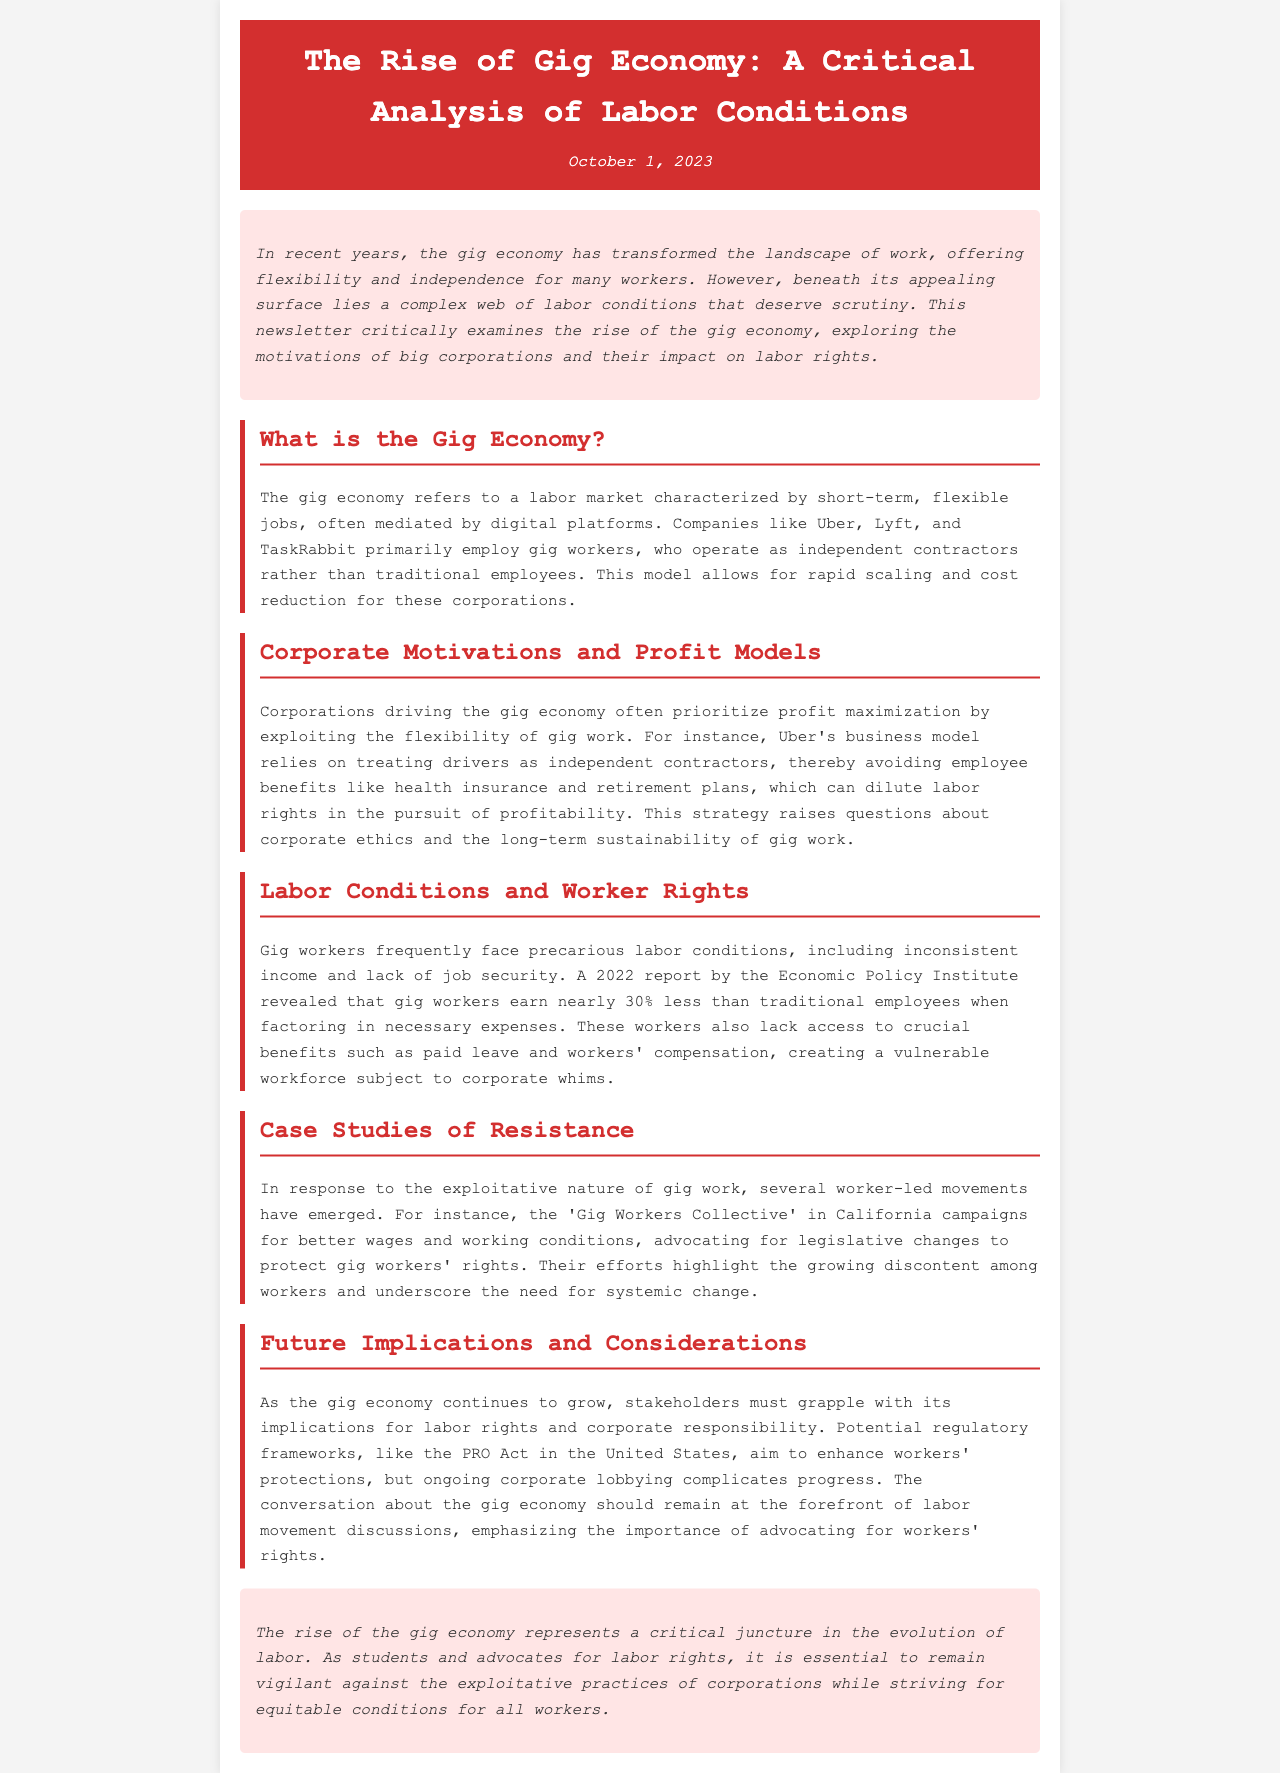What is the date of the newsletter? The date mentioned in the newsletter is October 1, 2023.
Answer: October 1, 2023 Who are some companies mentioned in the gig economy section? The newsletter lists Uber, Lyft, and TaskRabbit as examples of companies in the gig economy.
Answer: Uber, Lyft, TaskRabbit What percentage less do gig workers earn compared to traditional employees? According to the 2022 report, gig workers earn nearly 30% less than traditional employees.
Answer: 30% What is the name of the campaign mentioned for gig workers' rights? The organization campaigning for better wages and working conditions for gig workers is called the 'Gig Workers Collective.'
Answer: Gig Workers Collective What is one potential regulatory framework mentioned that aims to enhance workers’ protections? The newsletter refers to the PRO Act as a regulatory framework impacting gig workers' protections.
Answer: PRO Act What type of labor conditions do gig workers frequently face? The document indicates that gig workers frequently face precarious labor conditions.
Answer: Precarious labor conditions What should the conversation about the gig economy emphasize according to the future implications section? The conversation about the gig economy should emphasize the importance of advocating for workers' rights.
Answer: Advocating for workers' rights Who authored the critical analysis about the gig economy? The newsletter does not explicitly mention an author, but it likely reflects the perspectives of labor movement advocates as mentioned in the conclusion.
Answer: Not specified 